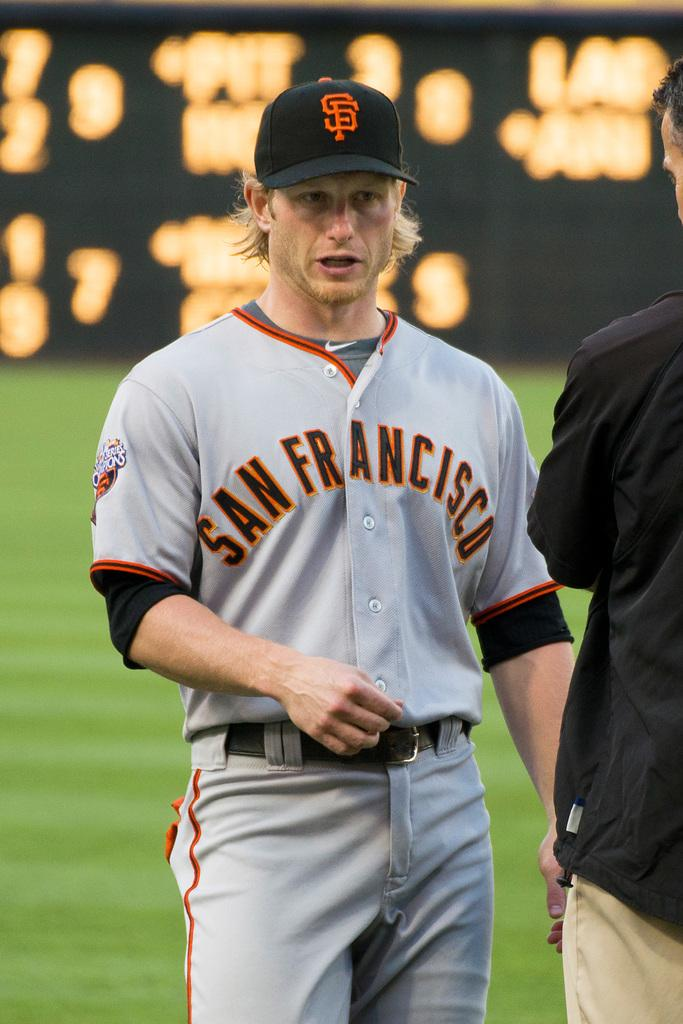Provide a one-sentence caption for the provided image. A player in a grey jersey with San Francisco written on it. 